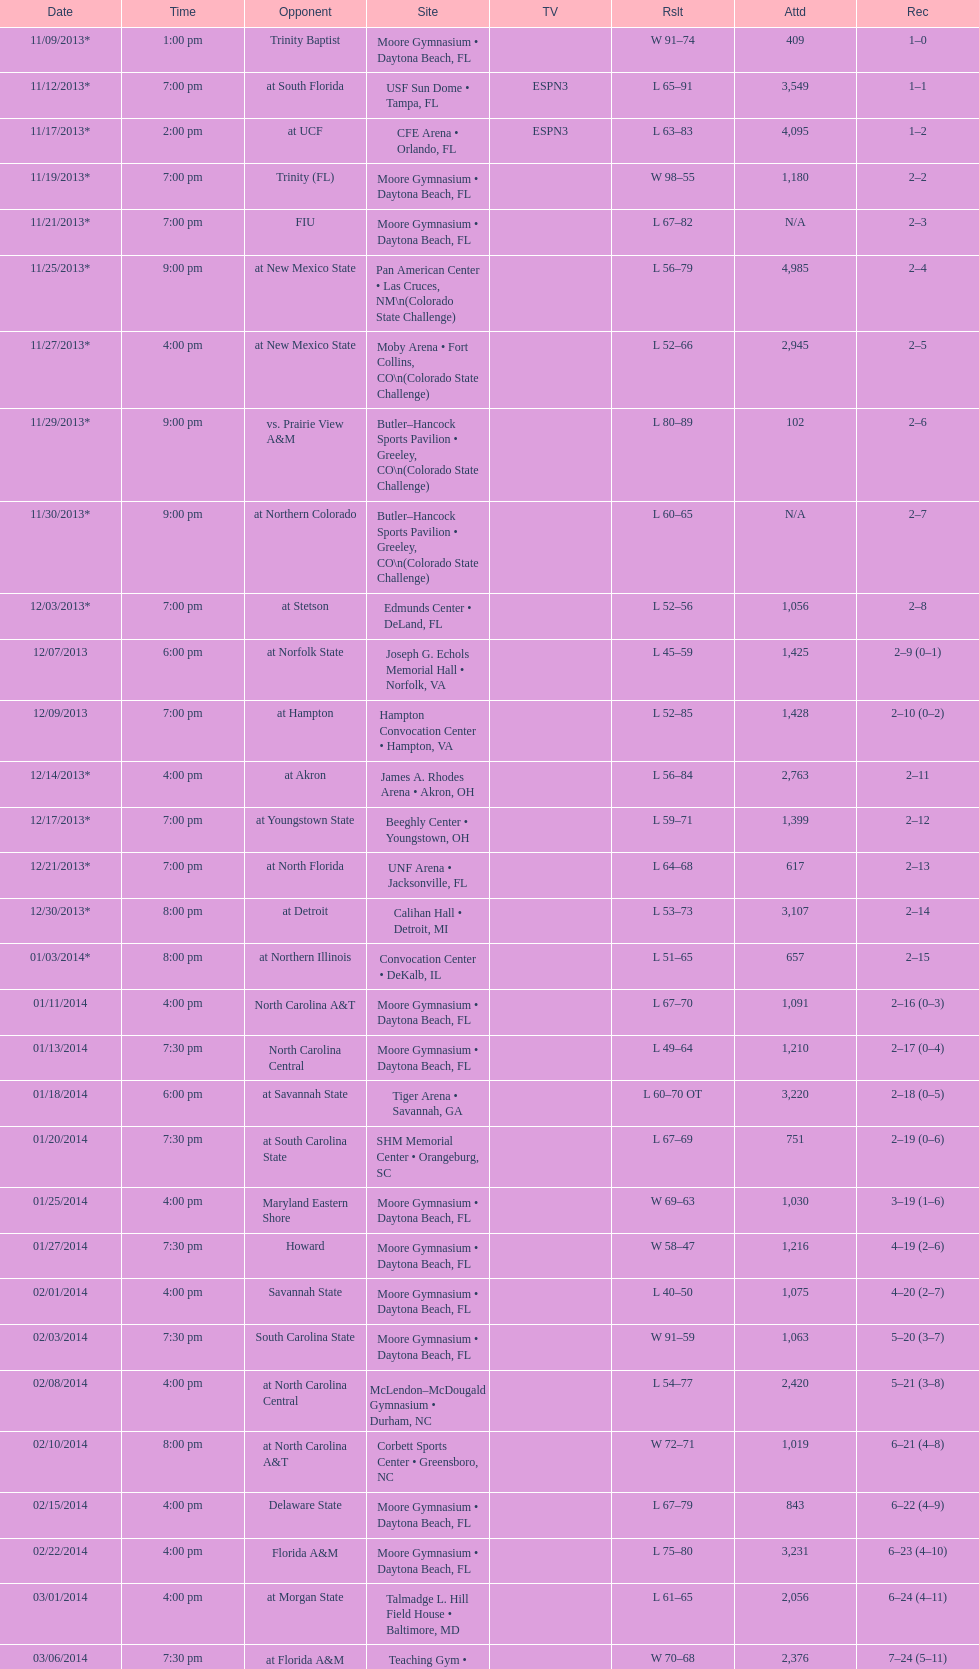Which game was won by a bigger margin, against trinity (fl) or against trinity baptist? Trinity (FL). 